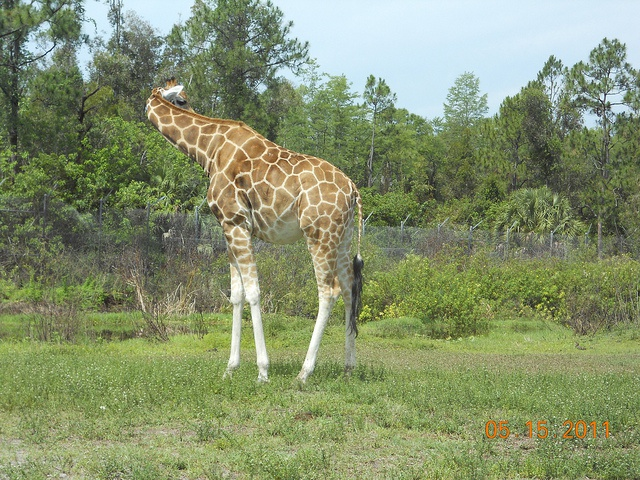Describe the objects in this image and their specific colors. I can see a giraffe in gray, tan, beige, and olive tones in this image. 